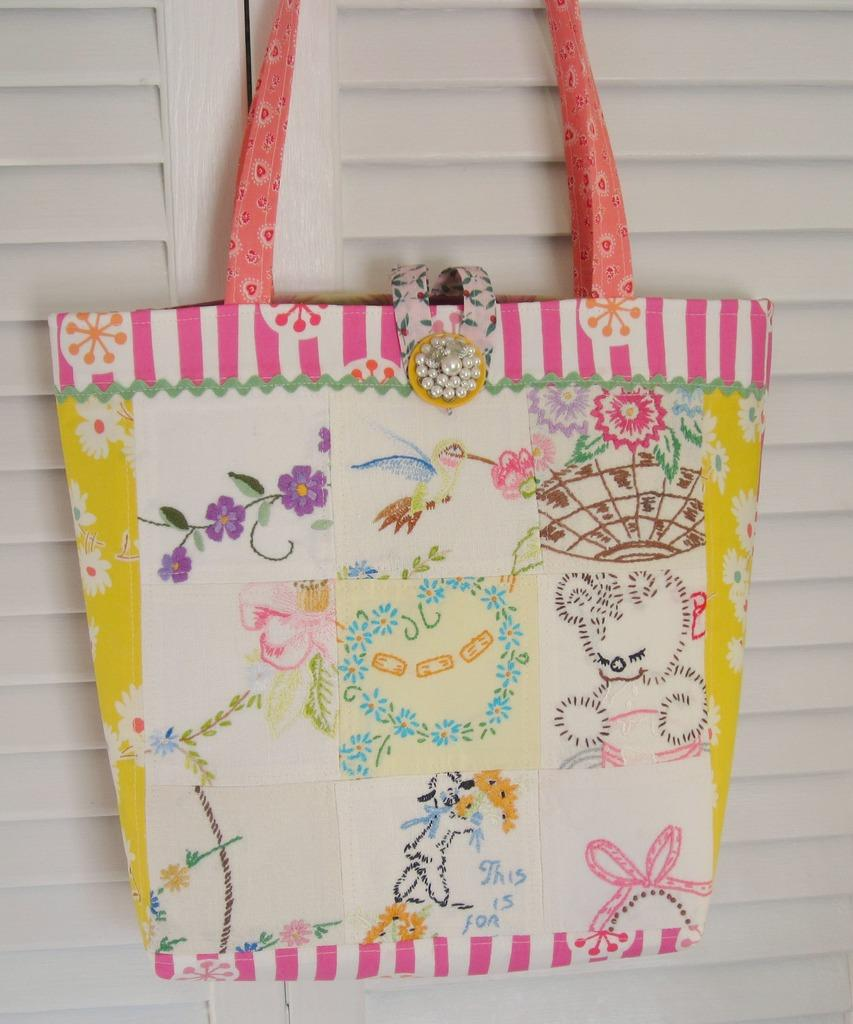What object is present in the picture? There is a bag in the picture. What is on the surface of the bag? The bag has many crafts on it. How would you describe the appearance of the bag? The bag is multi-colored and has a pink handle. Where is the bag located in the image? The bag is hung on a door. What color is the door? The door is white. Can you see any jewels on the door in the image? There are no jewels visible on the door in the image. Are there any ants crawling on the bag in the image? There are no ants present in the image. 